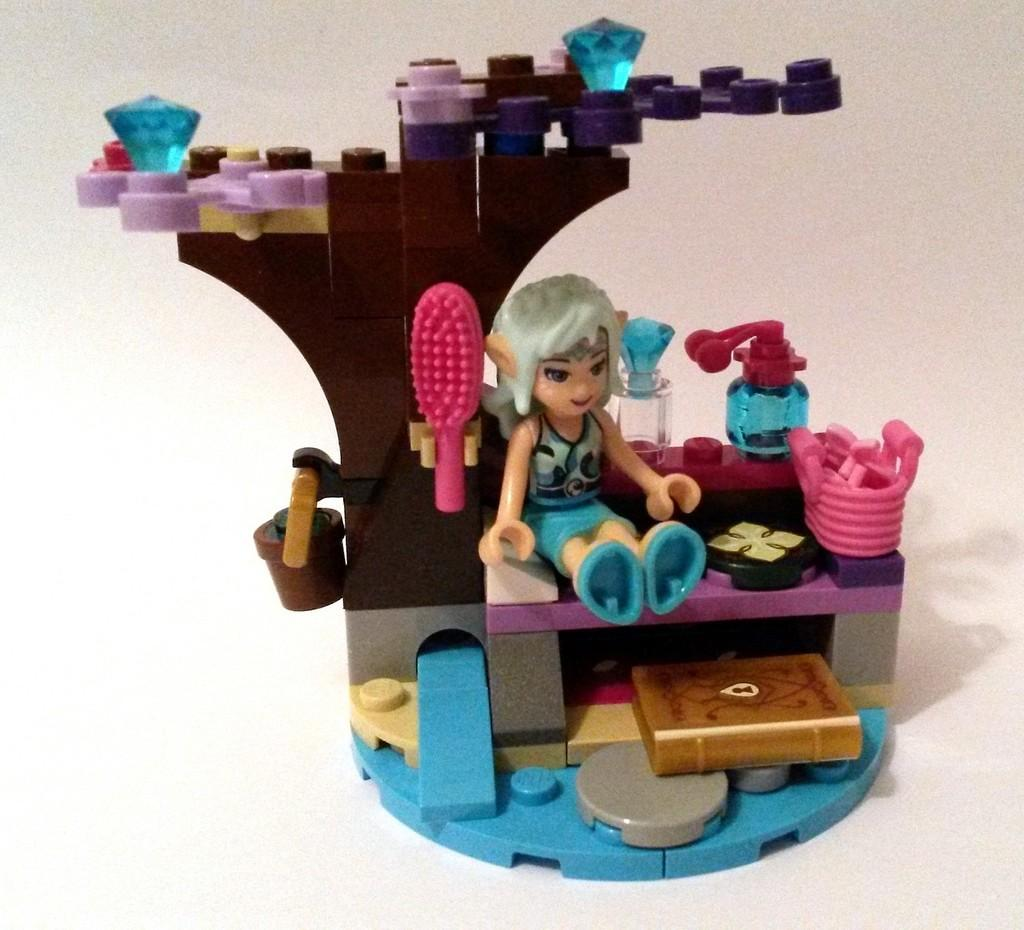What type of objects can be seen in the image? There are toys in the image. What type of trousers are the toys wearing in the image? Toys do not wear trousers, as they are inanimate objects. The question is not relevant to the image, as there is no mention of trousers or any clothing items in the provided facts. 